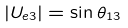Convert formula to latex. <formula><loc_0><loc_0><loc_500><loc_500>| U _ { e 3 } | = \sin \theta _ { 1 3 }</formula> 